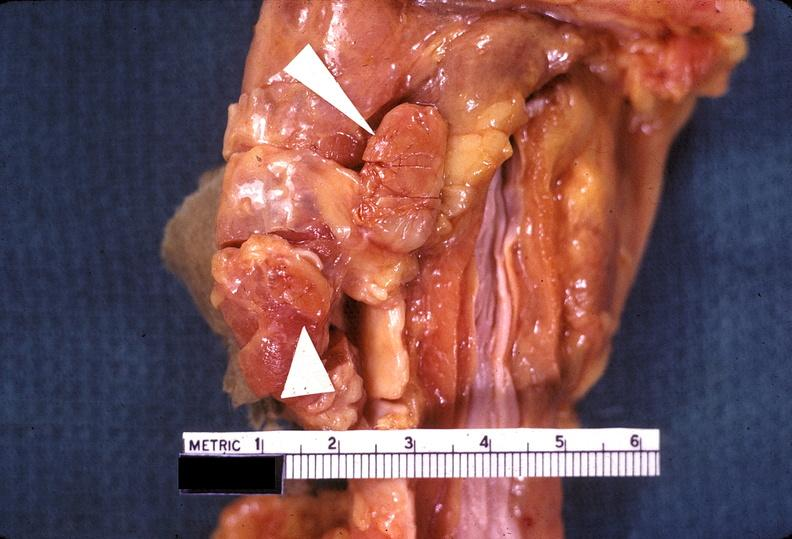where does this belong to?
Answer the question using a single word or phrase. Endocrine system 